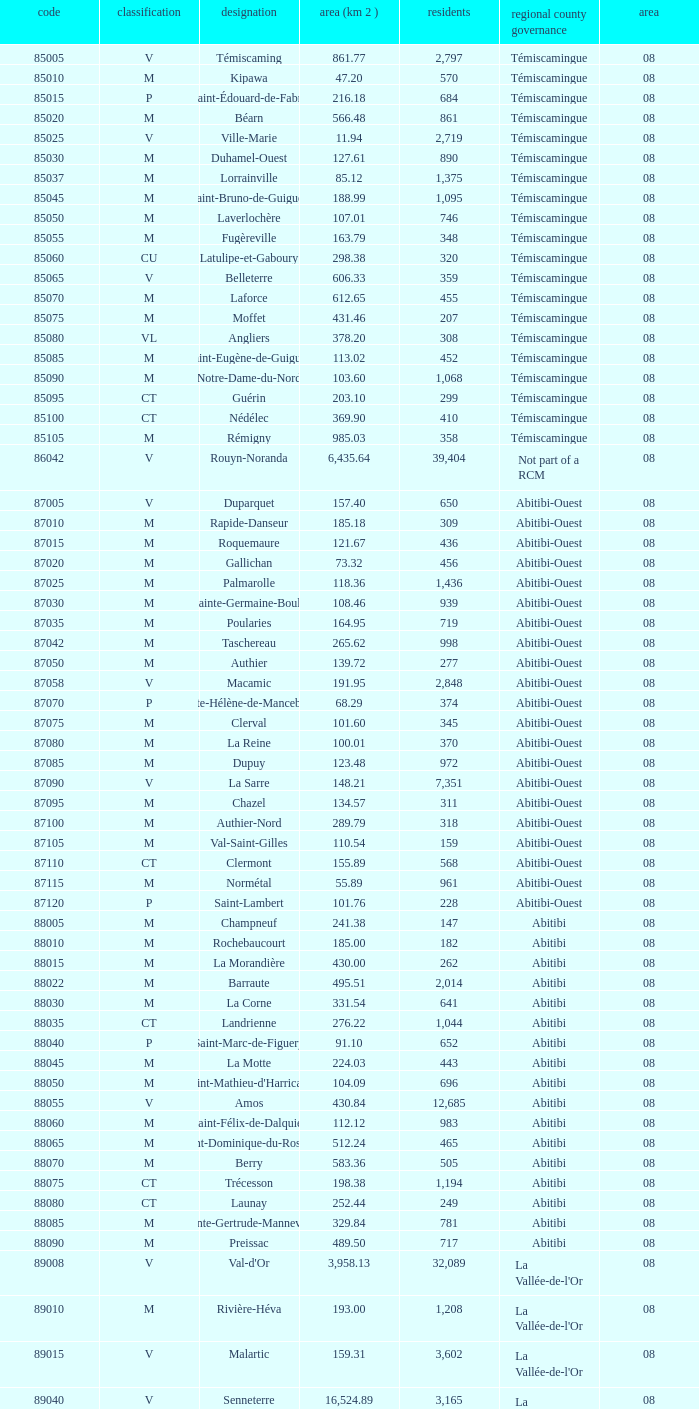What was the region for Malartic with 159.31 km2? 0.0. 